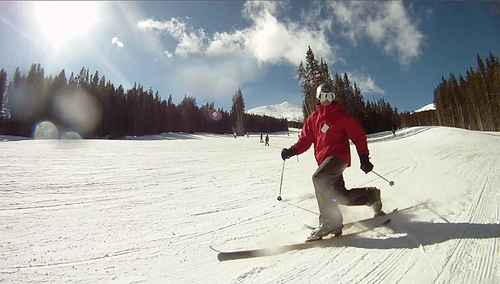What is causing the glare in the image?
A. street lights
B. sun
C. torches
D. flashlights
Answer with the option's letter from the given choices directly. B 